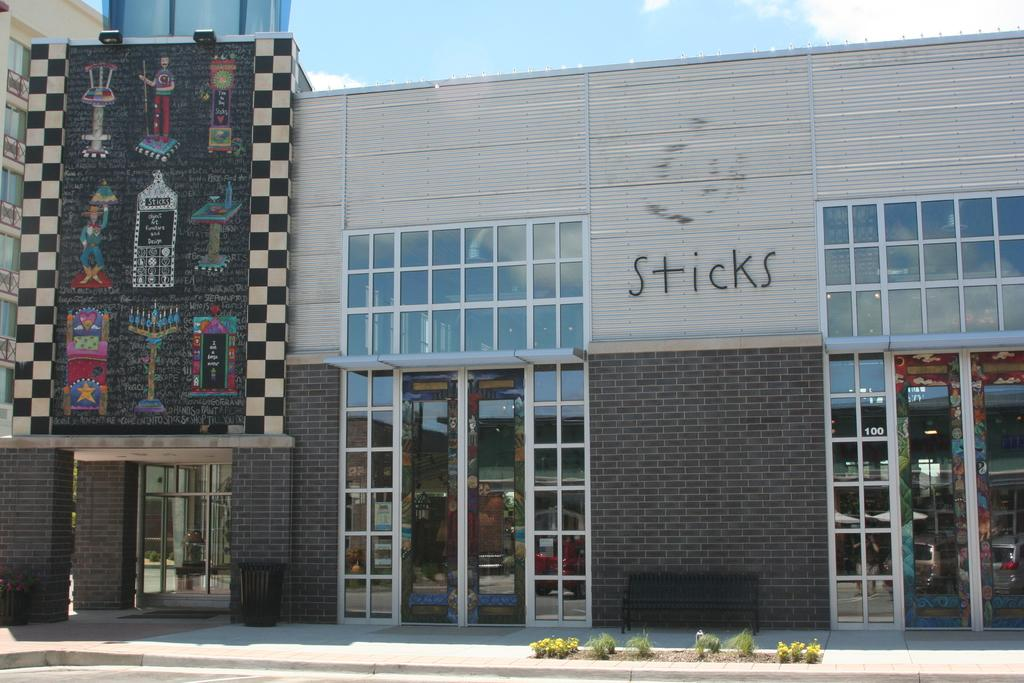Provide a one-sentence caption for the provided image. A building with a colorful mural outside named Sticks. 